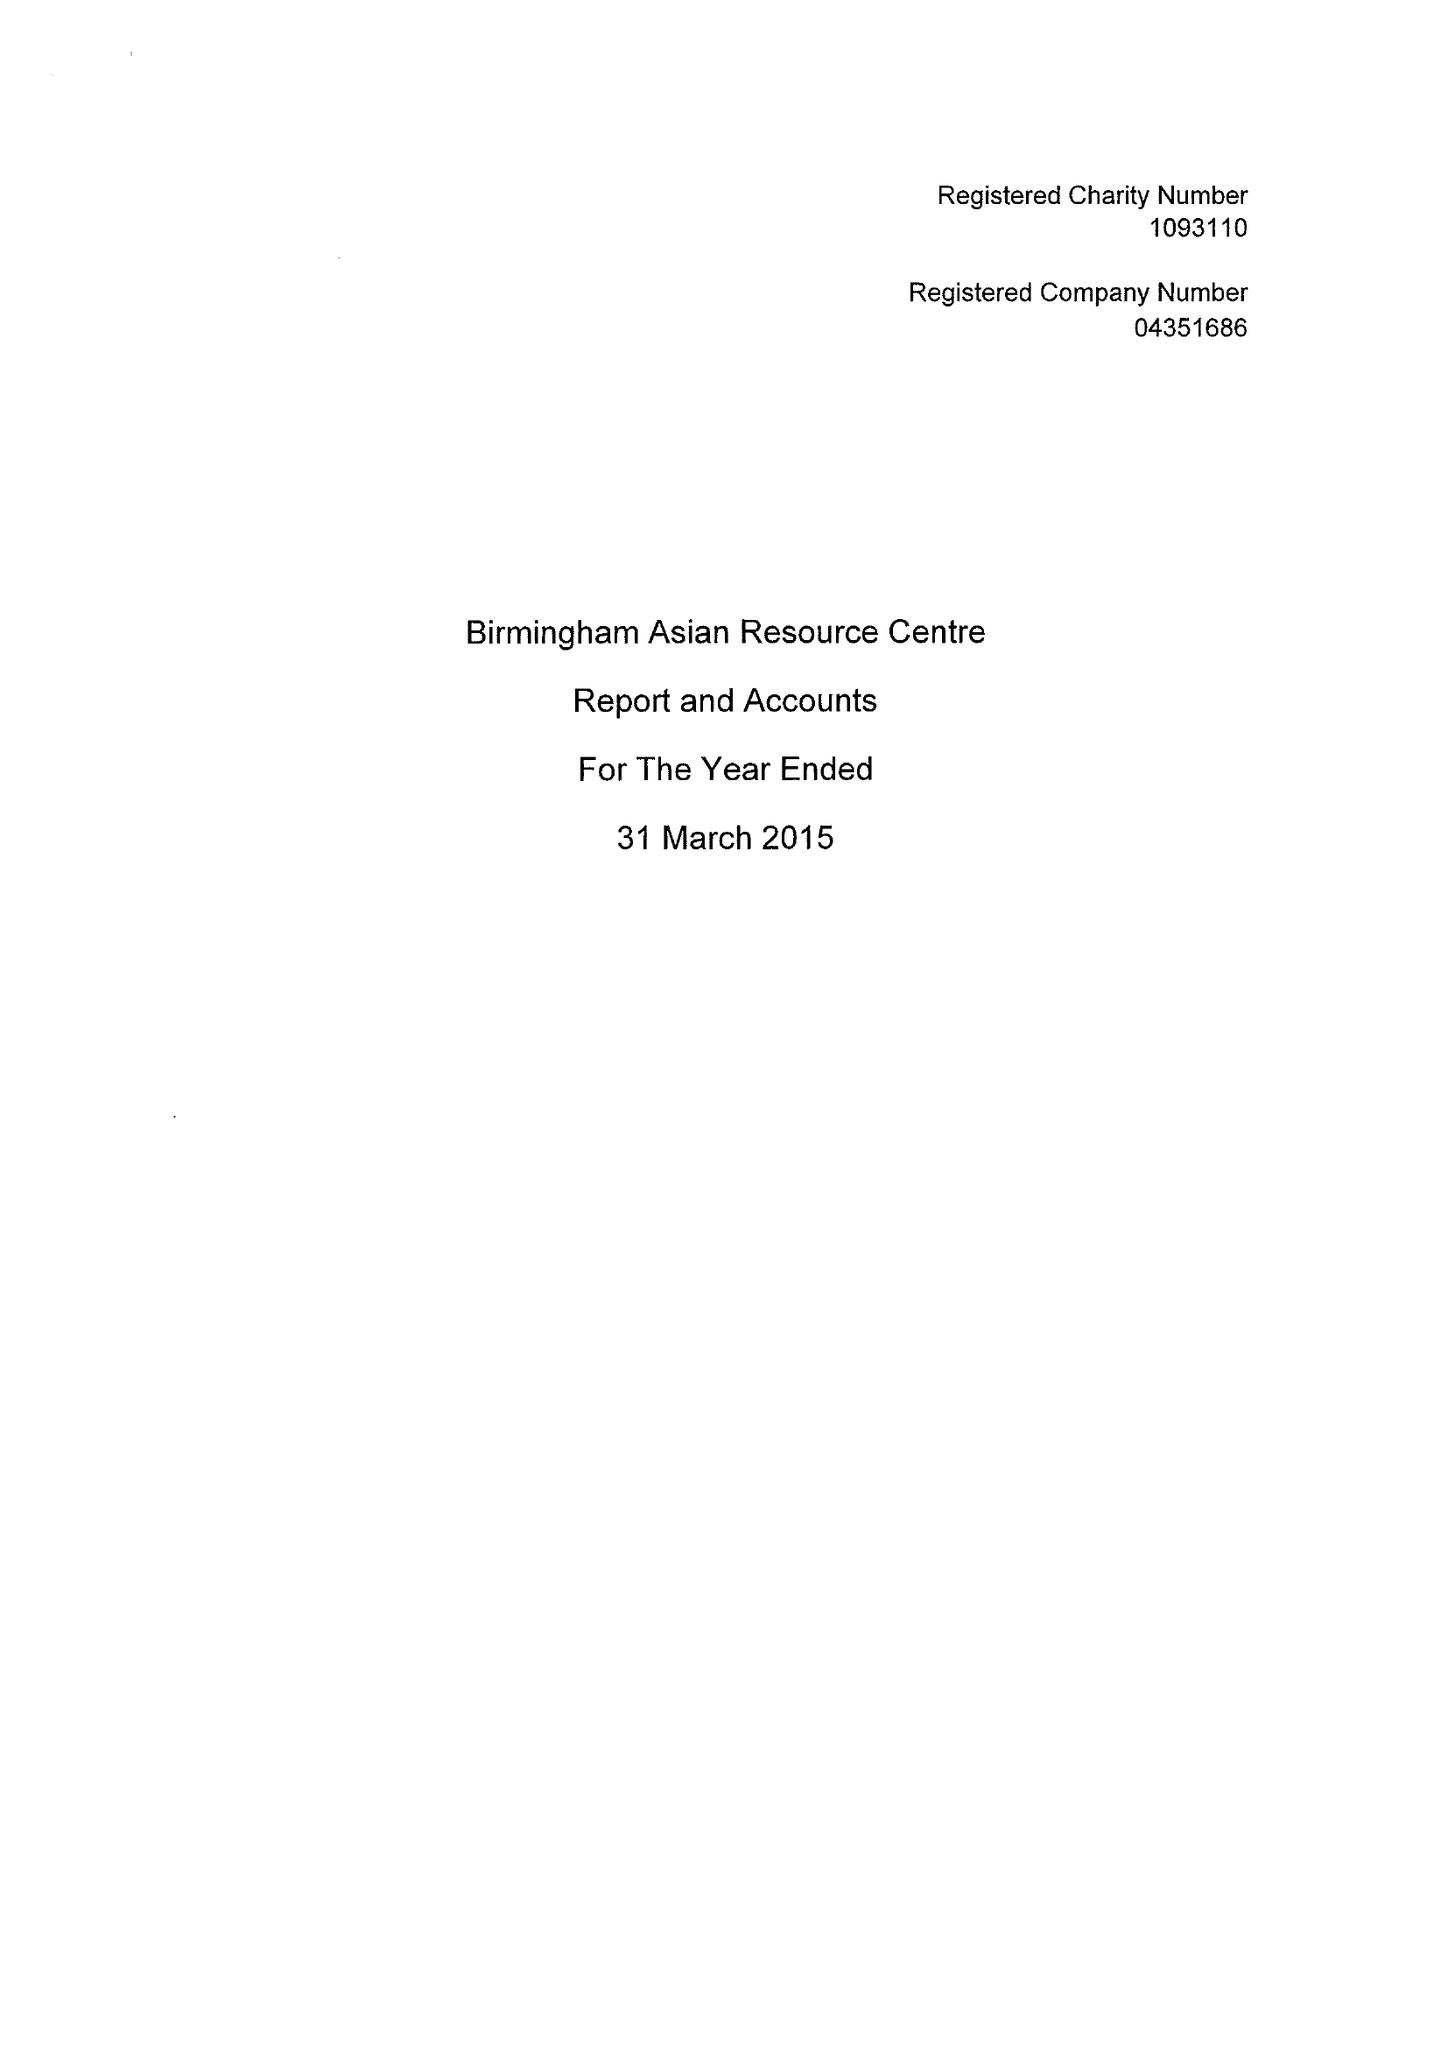What is the value for the address__post_town?
Answer the question using a single word or phrase. BIRMINGHAM 